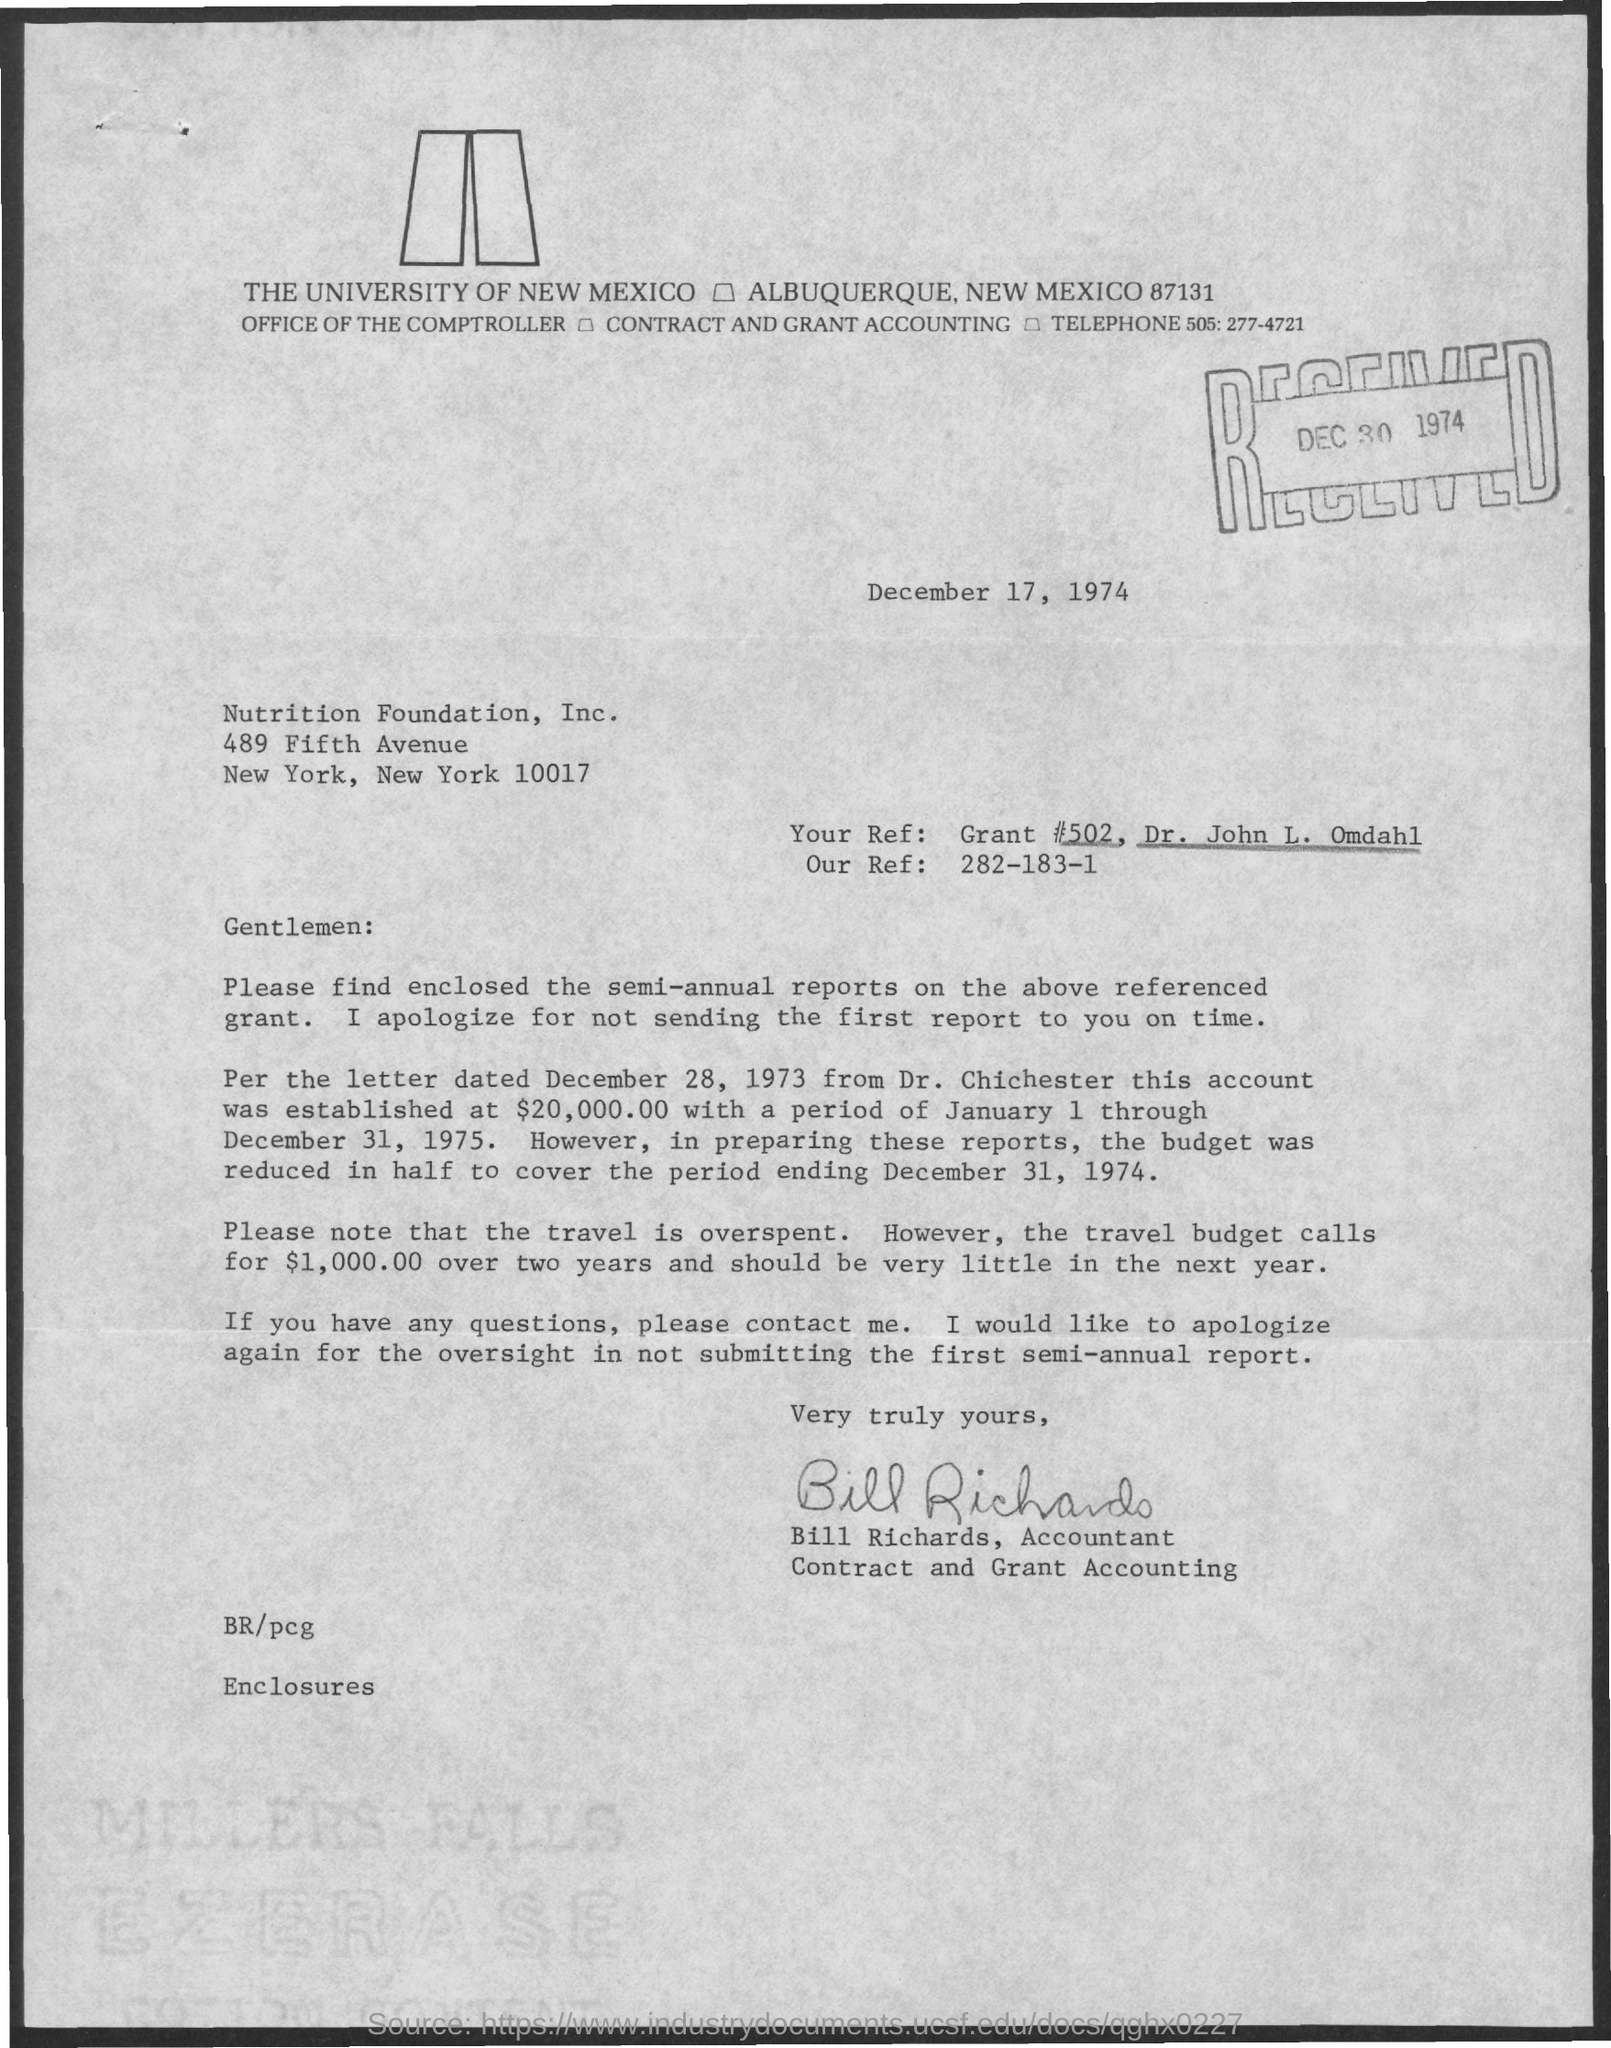Outline some significant characteristics in this image. The letter is from Bill Richards. The date on the document is December 17, 1974. What is 'Your Ref:'? It is a reference number, specifically Grant #502, assigned to Dr. John L. Omdahl. Our Ref:" refers to a specific reference or identifier. 